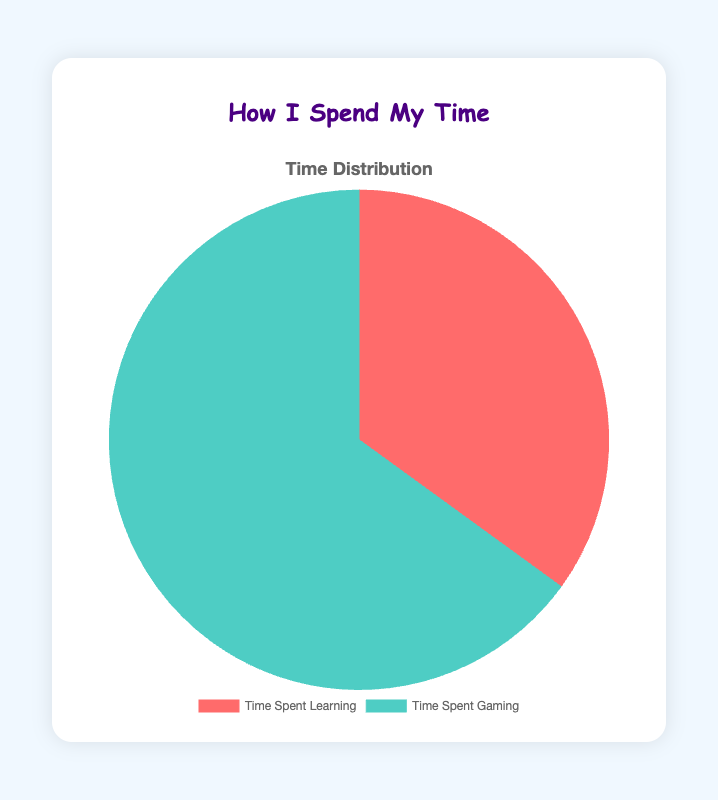What percentage of time is spent learning? The pie chart shows that "Time Spent Learning" accounts for 35% of the total time. This value is directly noted in the chart's data.
Answer: 35% Which activity takes up more time? By comparing the percentages in the pie chart, "Time Spent Gaming" takes up a larger portion of the chart with 65% compared to "Time Spent Learning," which is 35%.
Answer: Time Spent Gaming What is the ratio of time spent learning to gaming? The ratio can be calculated by dividing the two time points given: 35 (learning) divided by 65 (gaming). Simplify the fraction: 35/65 = 7/13.
Answer: 7:13 How much more time is spent gaming compared to learning? The difference shows that gaming takes up 65% and learning takes up 35%. Subtracting these values gives: 65 - 35 = 30%.
Answer: 30% What is the difference between the time spent learning and gaming? From the pie chart, "Time Spent Gaming" is 65% and "Time Spent Learning" is 35%. Subtracting these two values yields: 65% - 35% = 30%.
Answer: 30% If you combined time spent on learning and gaming, what would be the total percentage? Adding the two percentages from the pie chart: 35% (learning) and 65% (gaming) equals a total of: 35% + 65% = 100%.
Answer: 100% Which segment is larger in the pie chart? By looking at the pie chart, "Time Spent Gaming" occupies a larger segment (65%) than "Time Spent Learning" (35%).
Answer: Time Spent Gaming What's the color of the segment representing time spent learning? The pie chart visually represents "Time Spent Learning" in red.
Answer: Red What's the color of the section for time spent gaming? The chart shows "Time Spent Gaming" in a teal color.
Answer: Teal If time spent learning was increased by 10%, how would that affect the total distribution? Increasing "Time Spent Learning" by 10% would result in 45% learning and 65% gaming, totaling 110%, which isn't feasible since the total should be 100%. It means a rebalancing needs to occur, impacting both categories. This would require adjusting the percentages so they still sum to 100%.
Answer: Adjustments needed 